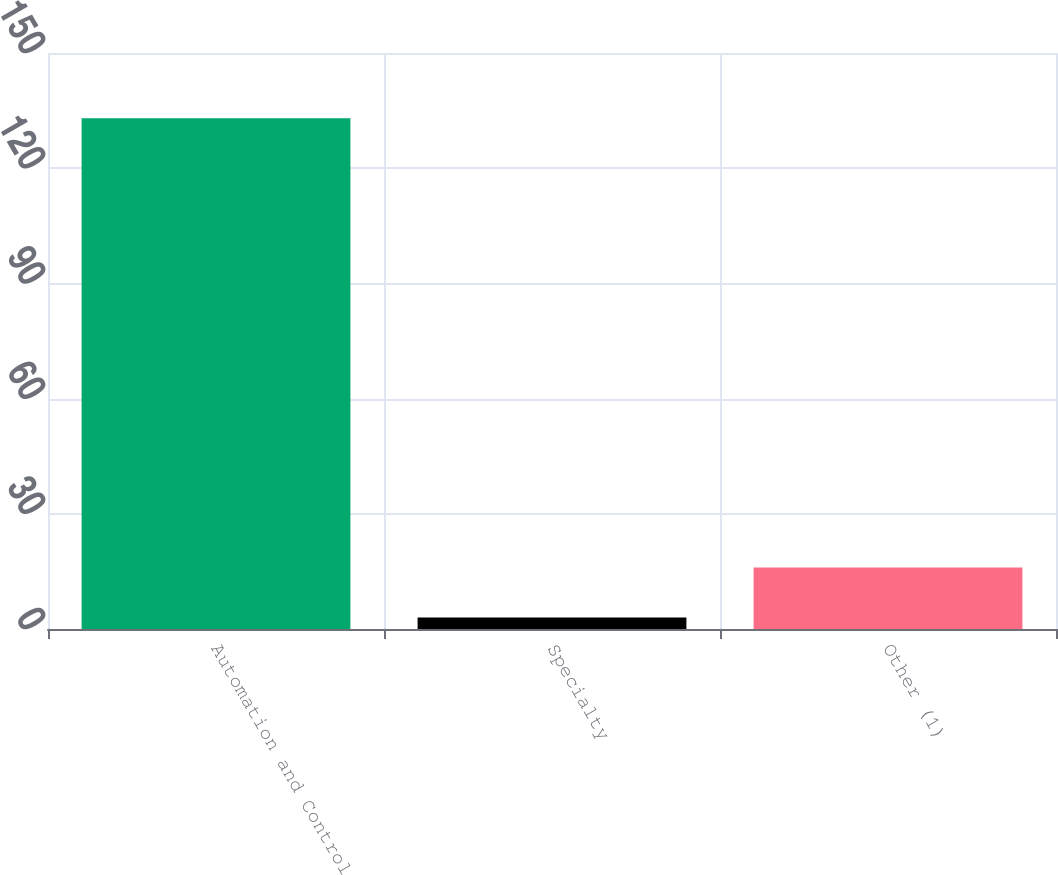Convert chart. <chart><loc_0><loc_0><loc_500><loc_500><bar_chart><fcel>Automation and Control<fcel>Specialty<fcel>Other (1)<nl><fcel>133<fcel>3<fcel>16<nl></chart> 